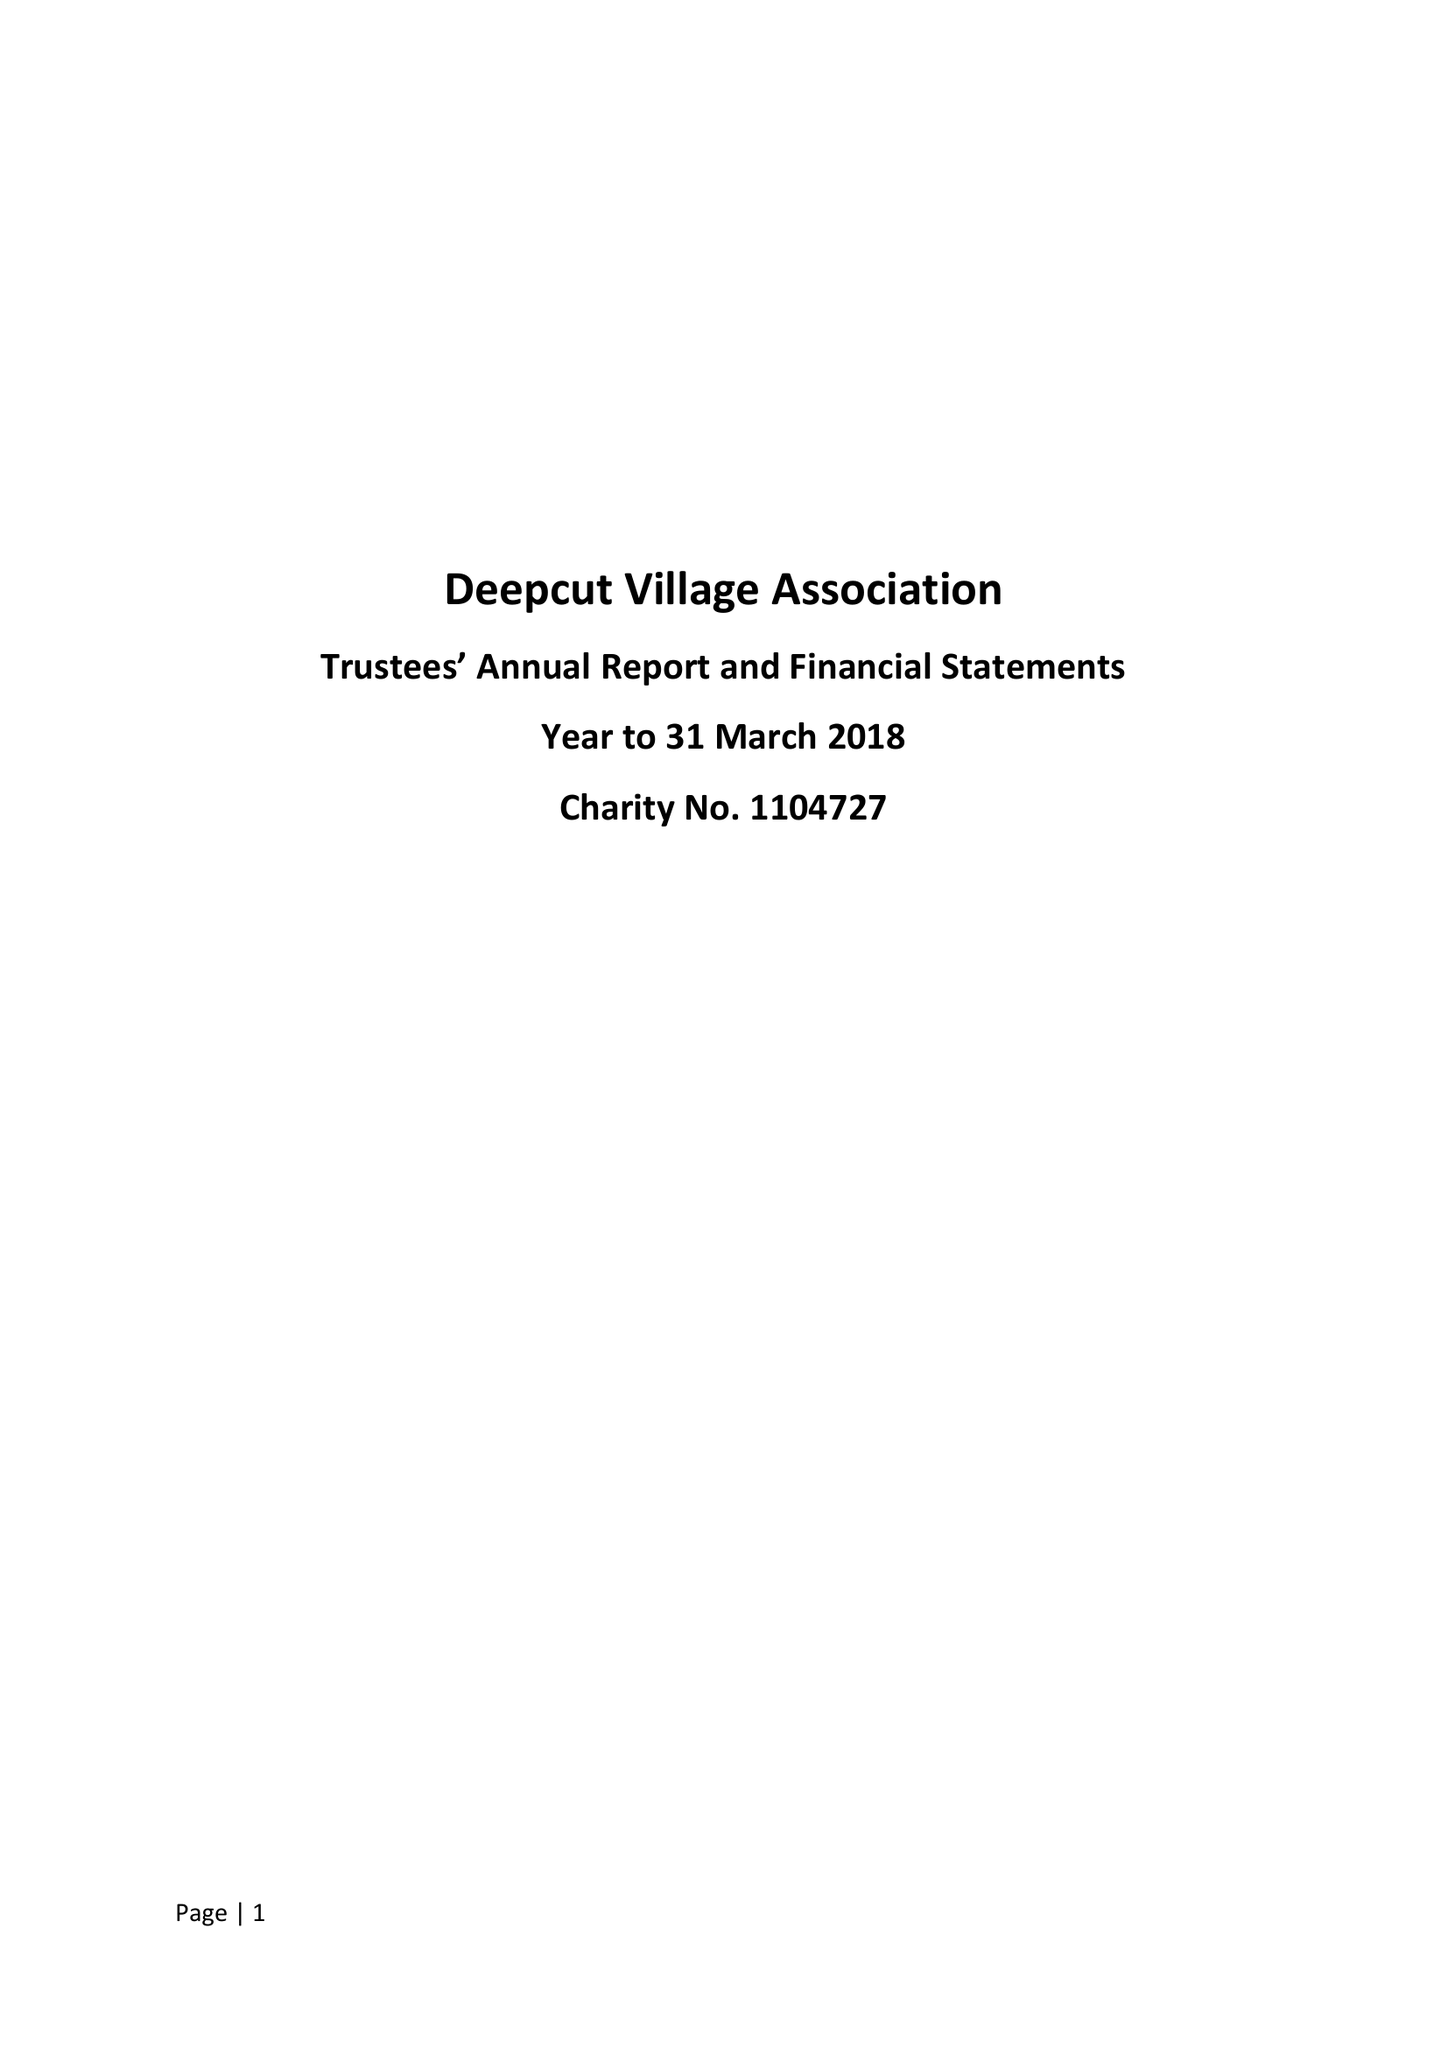What is the value for the address__street_line?
Answer the question using a single word or phrase. None 